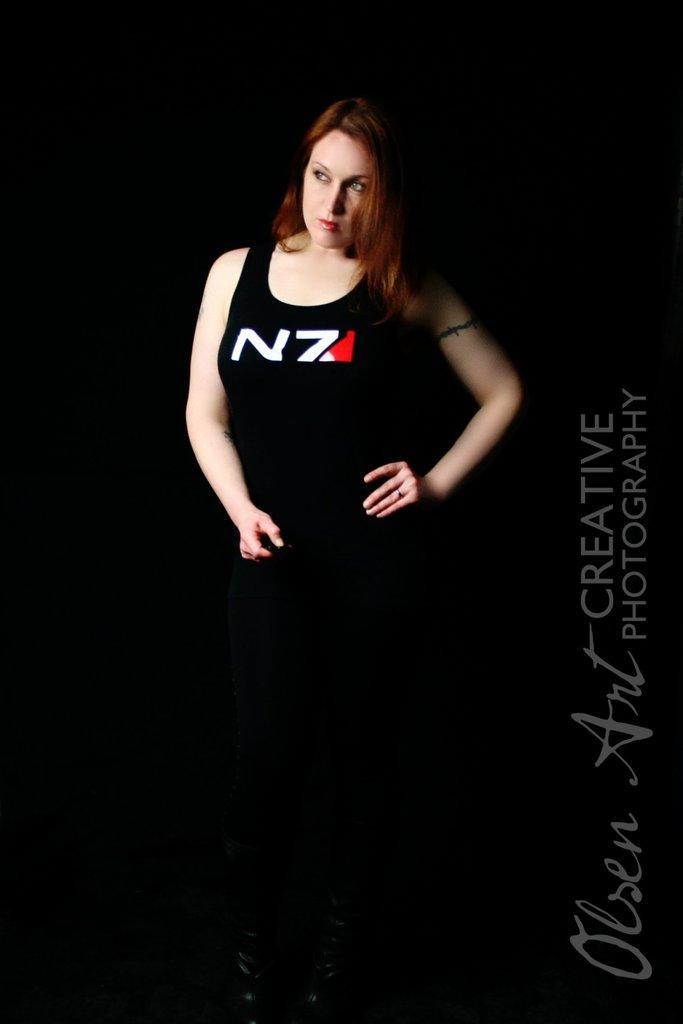Could you give a brief overview of what you see in this image? In this image I can see a person and text visible on right side and background is dark. 